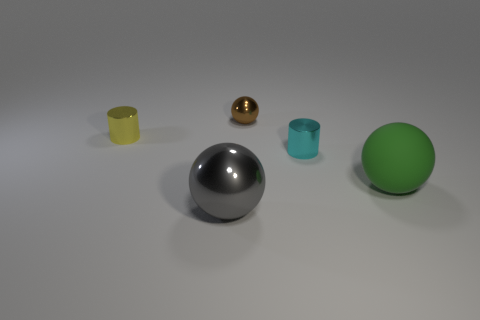Add 4 small objects. How many objects exist? 9 Subtract all spheres. How many objects are left? 2 Subtract 2 spheres. How many spheres are left? 1 Subtract all yellow spheres. Subtract all purple blocks. How many spheres are left? 3 Subtract all gray cylinders. How many green balls are left? 1 Subtract all tiny green metal balls. Subtract all yellow metallic things. How many objects are left? 4 Add 1 tiny cyan objects. How many tiny cyan objects are left? 2 Add 4 tiny gray balls. How many tiny gray balls exist? 4 Subtract all green spheres. How many spheres are left? 2 Subtract all gray balls. How many balls are left? 2 